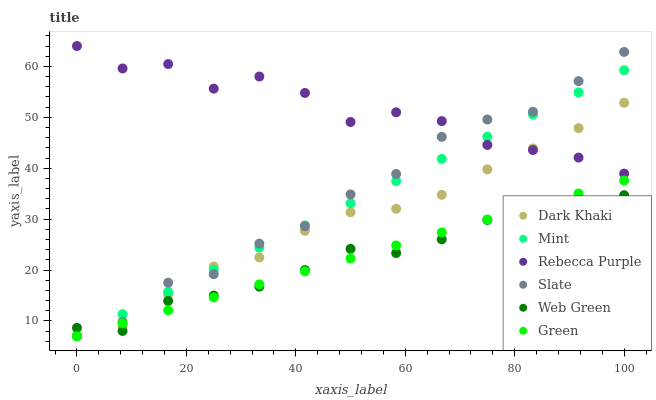Does Web Green have the minimum area under the curve?
Answer yes or no. Yes. Does Rebecca Purple have the maximum area under the curve?
Answer yes or no. Yes. Does Dark Khaki have the minimum area under the curve?
Answer yes or no. No. Does Dark Khaki have the maximum area under the curve?
Answer yes or no. No. Is Green the smoothest?
Answer yes or no. Yes. Is Rebecca Purple the roughest?
Answer yes or no. Yes. Is Web Green the smoothest?
Answer yes or no. No. Is Web Green the roughest?
Answer yes or no. No. Does Slate have the lowest value?
Answer yes or no. Yes. Does Web Green have the lowest value?
Answer yes or no. No. Does Rebecca Purple have the highest value?
Answer yes or no. Yes. Does Dark Khaki have the highest value?
Answer yes or no. No. Is Web Green less than Rebecca Purple?
Answer yes or no. Yes. Is Rebecca Purple greater than Green?
Answer yes or no. Yes. Does Mint intersect Web Green?
Answer yes or no. Yes. Is Mint less than Web Green?
Answer yes or no. No. Is Mint greater than Web Green?
Answer yes or no. No. Does Web Green intersect Rebecca Purple?
Answer yes or no. No. 